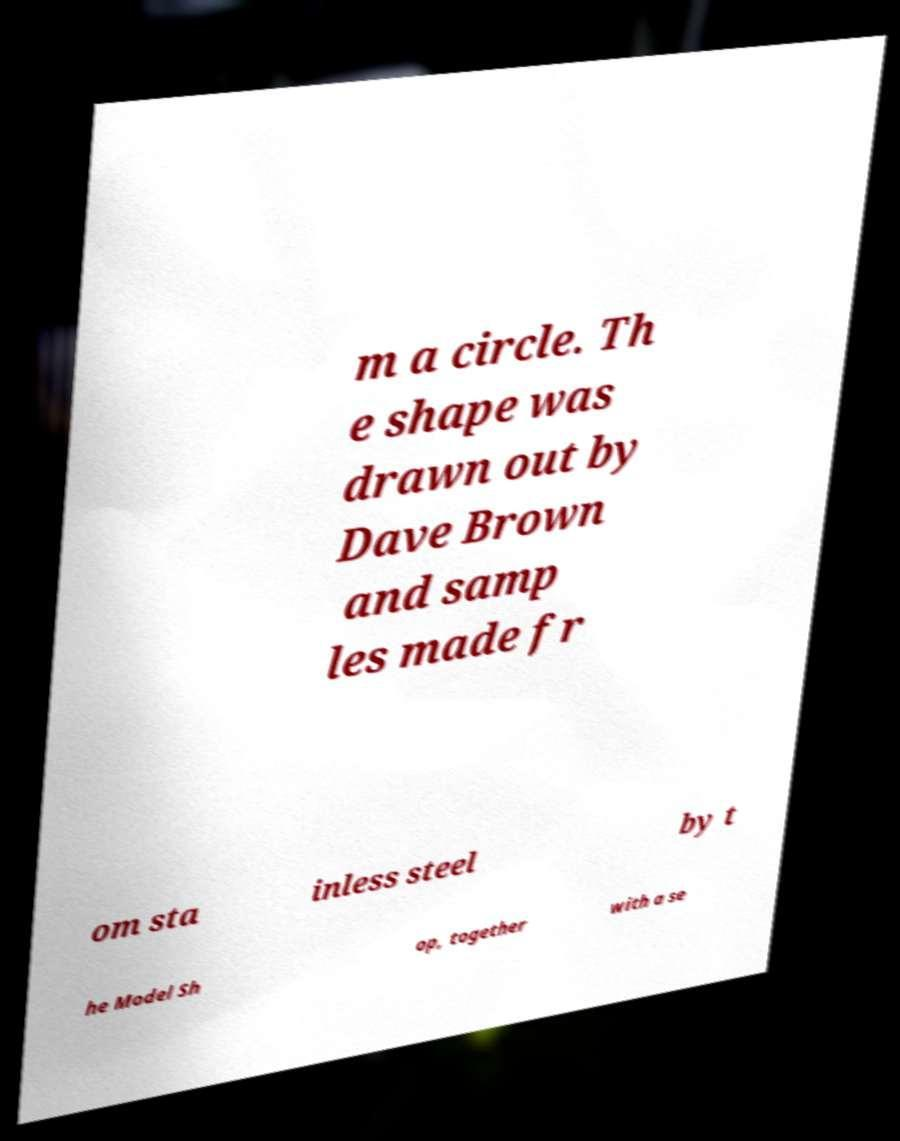For documentation purposes, I need the text within this image transcribed. Could you provide that? m a circle. Th e shape was drawn out by Dave Brown and samp les made fr om sta inless steel by t he Model Sh op, together with a se 